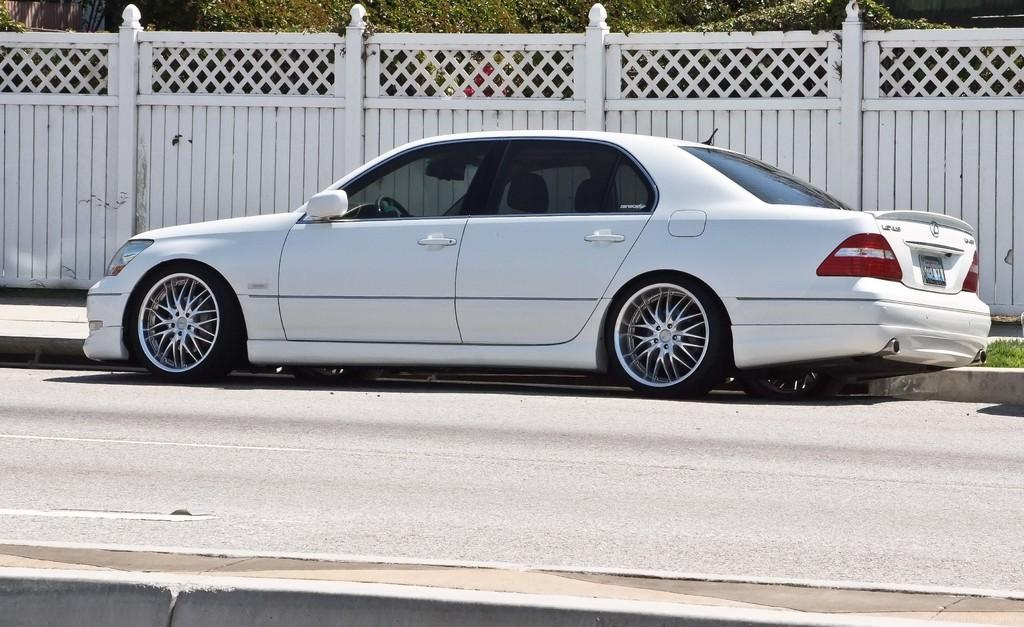What type of vegetation can be seen in the background of the image? There are trees in the background of the image. What architectural feature is present in the background of the image? There is a fence in the background of the image. What type of vehicle is on the road in the image? There is a white car on the road in the image. What type of ground cover is visible on the right side of the image? Grass is visible on the right side of the image. How does the distribution of flowers in the garden compare to the distribution of flowers in the neighboring garden? There is no garden or flowers mentioned in the image, so we cannot compare the distribution of flowers. 